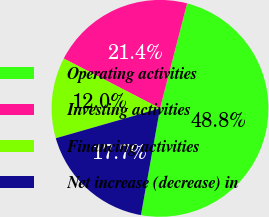<chart> <loc_0><loc_0><loc_500><loc_500><pie_chart><fcel>Operating activities<fcel>Investing activities<fcel>Financing activities<fcel>Net increase (decrease) in<nl><fcel>48.8%<fcel>21.42%<fcel>12.04%<fcel>17.74%<nl></chart> 